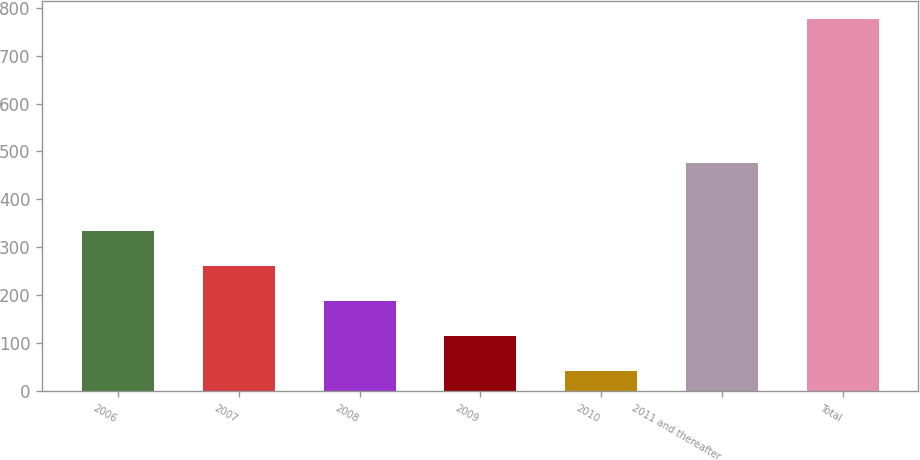Convert chart to OTSL. <chart><loc_0><loc_0><loc_500><loc_500><bar_chart><fcel>2006<fcel>2007<fcel>2008<fcel>2009<fcel>2010<fcel>2011 and thereafter<fcel>Total<nl><fcel>335<fcel>261.5<fcel>188<fcel>114.5<fcel>41<fcel>476<fcel>776<nl></chart> 